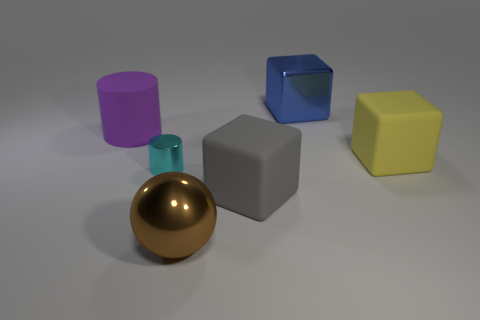Can you describe the lighting situation in the image? The scene in the image is illuminated with soft, diffused lighting coming from multiple directions. There are no harsh shadows, implying an evenly lit environment, perhaps in a studio setting. The reflections on the metallic sphere and the slight shadows cast by the objects offer clues to the light sources above and slightly to the side of the scene. 